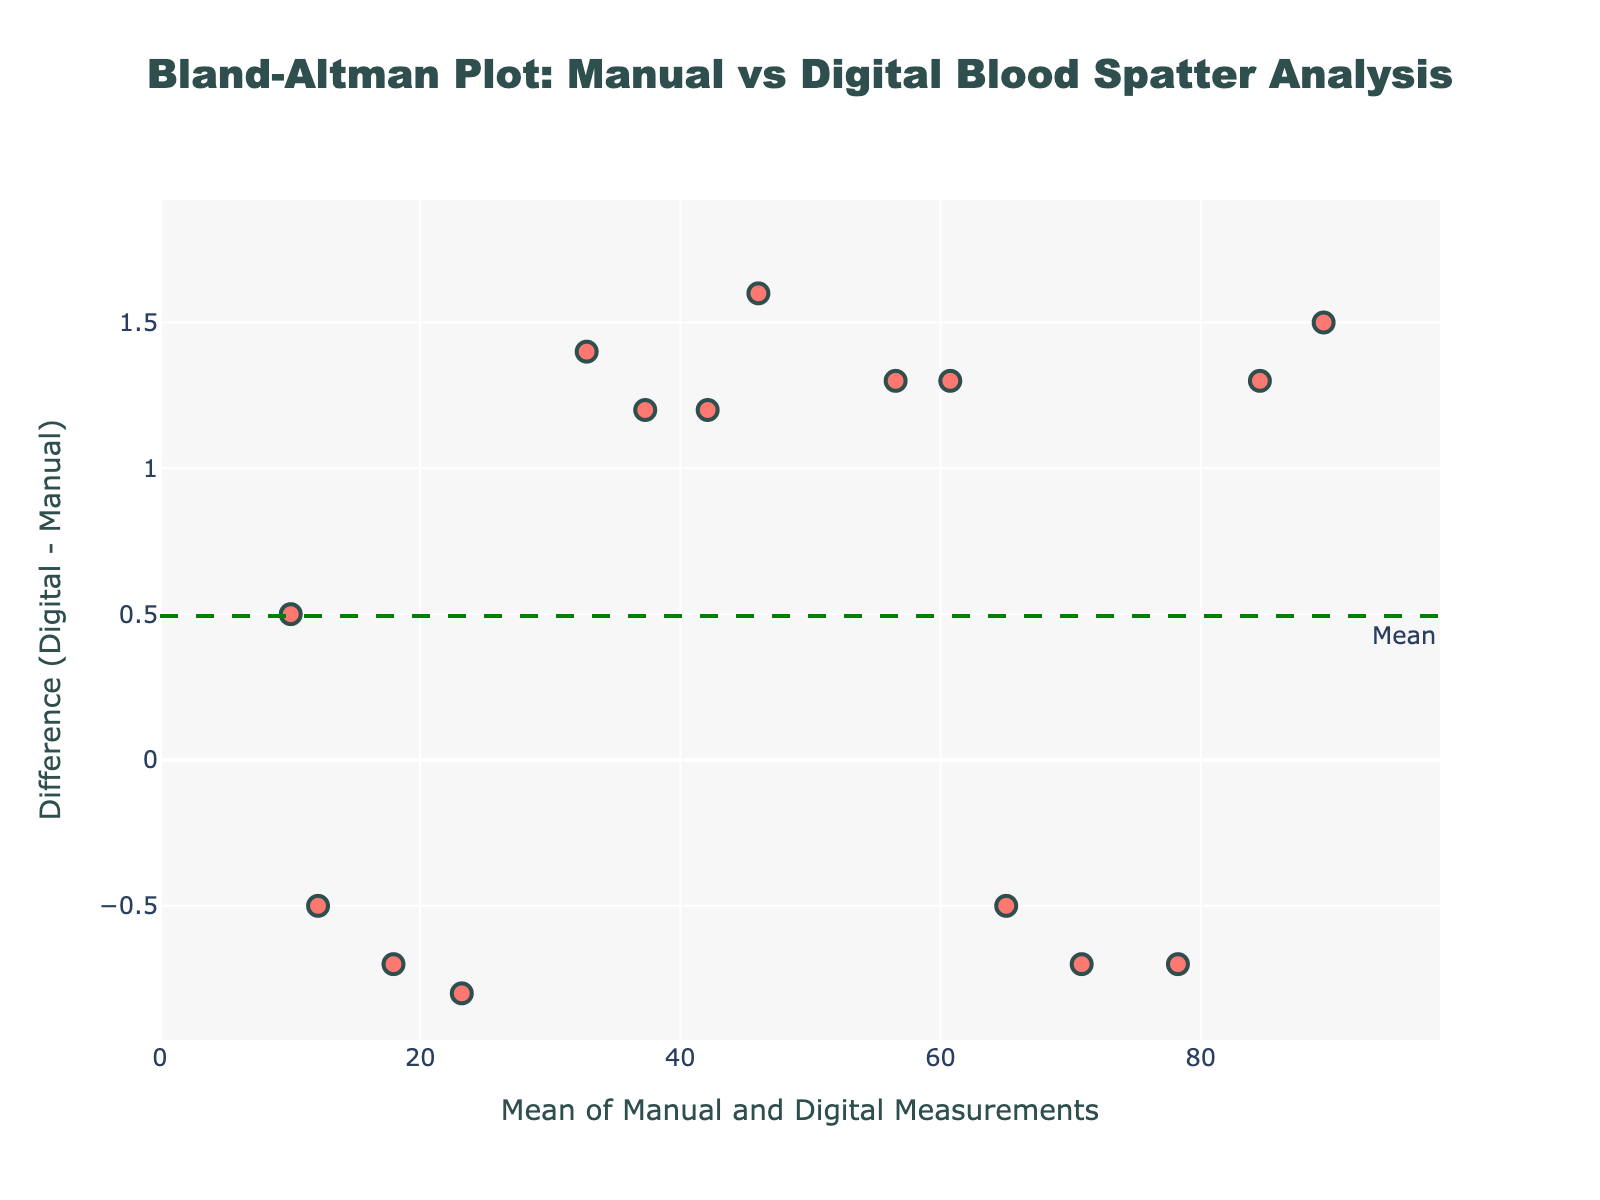How many data points are plotted on the Bland-Altman plot? Count the number of distinct markers (points) on the plot. Each marker represents one measurement comparison, and there are 15 data points listed in the provided data.
Answer: 15 What is the title of the plot? Read the title displayed at the top of the plot. The code specifies "Bland-Altman Plot: Manual vs Digital Blood Spatter Analysis".
Answer: Bland-Altman Plot: Manual vs Digital Blood Spatter Analysis What do the red dotted lines on the plot represent? These lines represent the limits of agreement, which are calculated as the mean difference plus and minus 1.96 times the standard deviation of the difference. This is a standard feature in Bland-Altman plots, illustrated by the annotations "+1.96 SD" and "-1.96 SD".
Answer: Limits of agreement Which measurement method has the largest positive difference between digital and manual methods? Check the y-values (difference) for each data point. The largest positive difference corresponds to the highest point on the plot. For Velocity_Estimation with a difference of 1.5 (90.2 - 88.7).
Answer: Velocity_Estimation What is the mean difference (Digital - Manual) shown on the plot? Identify the y-position of the green dashed line labeled "Mean". This line indicates the mean difference between the digital and manual measurements. This is calculated as \(0.413\) based on provided data's mean difference.
Answer: 0.413 Which measurement method shows the largest negative difference (Digital - Manual)? Identify the plot's data point with the lowest y-value. The largest negative difference corresponds to the lowest point on the plot. For Stain_Morphology, the difference is -0.5 (11.9 - 12.4).
Answer: Stain_Morphology What is the standard deviation of the differences? Calculate the spread of the differences by examining the distance between the mean line (green dashed) and the upper or lower limit (red dotted lines). Each red line is at \(1.96 \times SD\), resulting in SD being the distance divided by 1.96. This is given by \(SD = (1.650) / 1.96 ≈ 0.842\).
Answer: 0.842 Is there any measurement method where the manual and digital measurements are almost identical? Look at plot points that fall very close to the x-axis (difference = 0). Pattern_Classification (64.8-65.3) and Area_of_Origin (77.9 - 78.6) are closest.
Answer: Yes, Pattern_Classification For which measurement methods do the manual and digital measurements show a greater than 1 unit difference? Identify the y-values' magnitudes which indicate a difference greater than 1. These will be above 1 or below -1. Methods including Velocity_Estimation (1.5), Angle_of_Impact (1.4), and Droplet_Size_Analysis (-1.0) fit this criterion.
Answer: Velocity_Estimation, Angle_of_Impact, Droplet_Size_Analysis What does the green dashed line indicate on the plot? The green dashed line indicates the mean difference between the measured values by manual and digital methods. This line represents the average of all differences (Digital - Manual).
Answer: Mean difference 